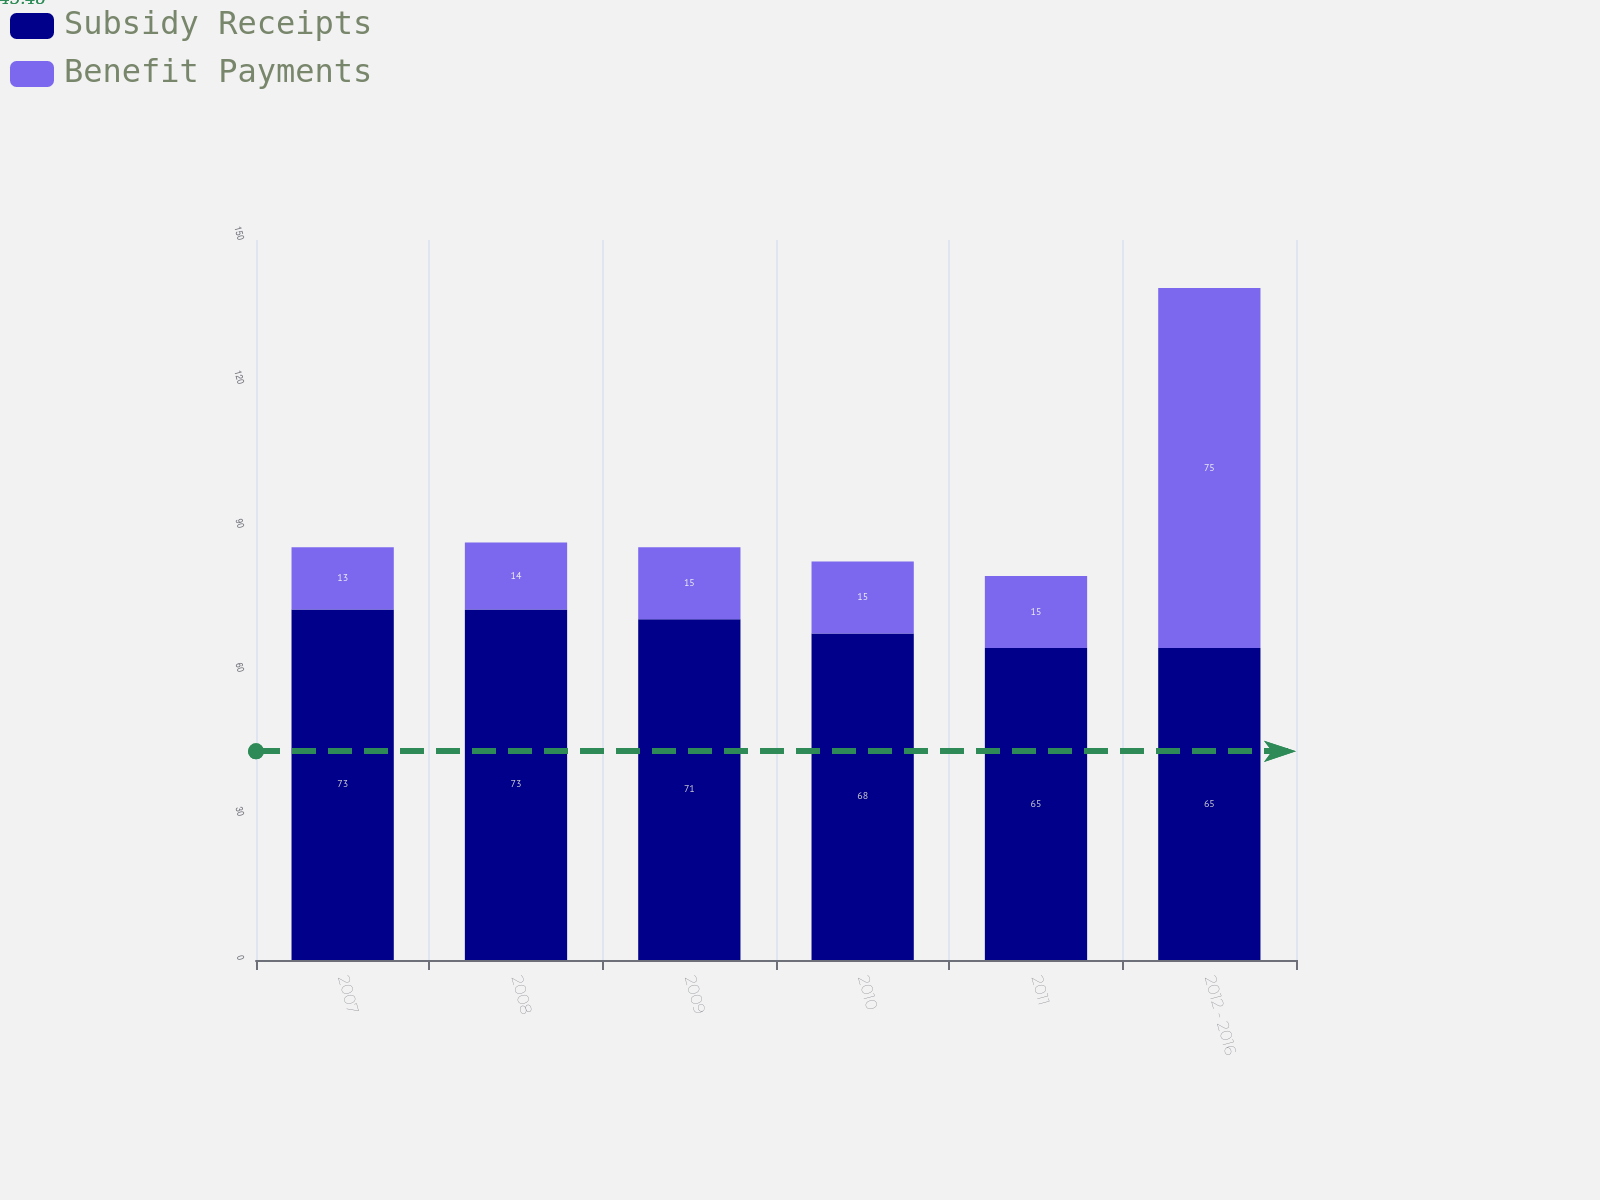Convert chart. <chart><loc_0><loc_0><loc_500><loc_500><stacked_bar_chart><ecel><fcel>2007<fcel>2008<fcel>2009<fcel>2010<fcel>2011<fcel>2012 - 2016<nl><fcel>Subsidy Receipts<fcel>73<fcel>73<fcel>71<fcel>68<fcel>65<fcel>65<nl><fcel>Benefit Payments<fcel>13<fcel>14<fcel>15<fcel>15<fcel>15<fcel>75<nl></chart> 